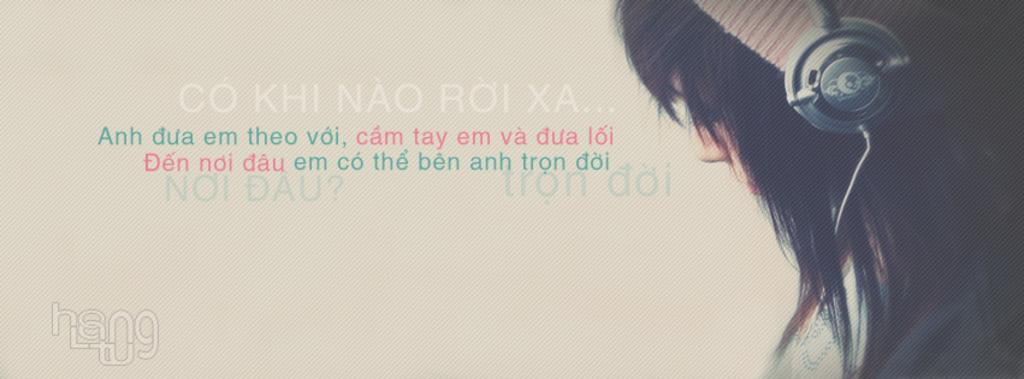What is the main subject of the image? There is a picture of a woman in the image. What is the woman wearing in the image? The woman is wearing headphones in the image. What else can be seen in the image besides the woman? There is text and a logo in the image. Can you tell me how many mountains are visible in the image? There are no mountains present in the image. What type of credit card is the woman using in the image? There is no credit card or any indication of a financial transaction in the image. 